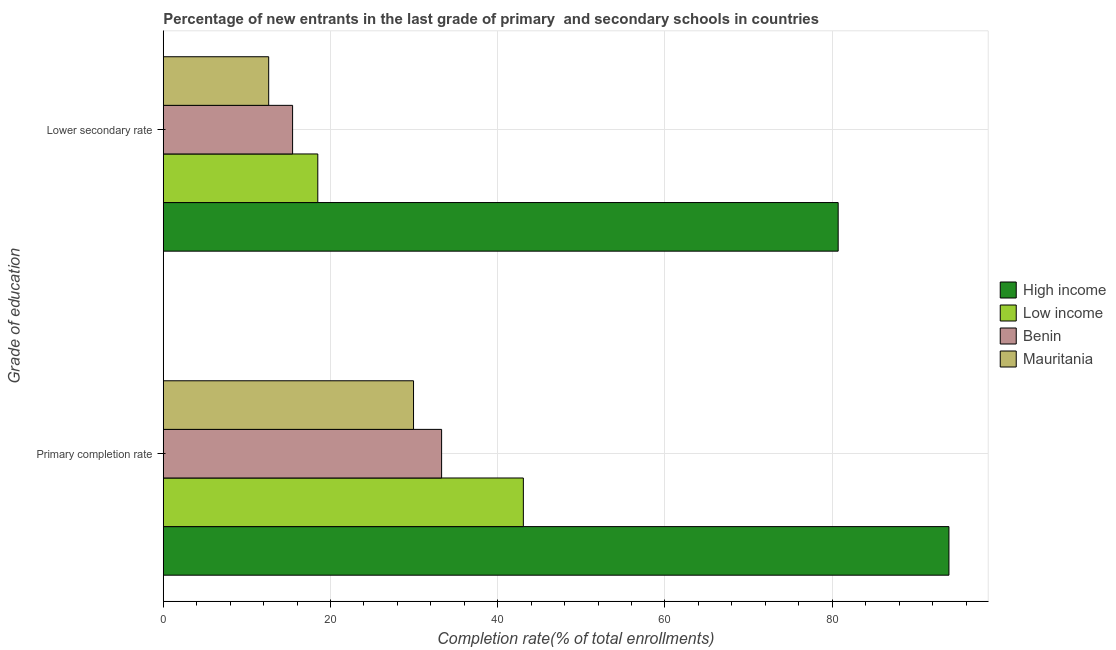How many different coloured bars are there?
Provide a succinct answer. 4. How many groups of bars are there?
Your answer should be compact. 2. Are the number of bars per tick equal to the number of legend labels?
Offer a very short reply. Yes. Are the number of bars on each tick of the Y-axis equal?
Provide a succinct answer. Yes. How many bars are there on the 1st tick from the top?
Keep it short and to the point. 4. What is the label of the 2nd group of bars from the top?
Your answer should be very brief. Primary completion rate. What is the completion rate in secondary schools in High income?
Provide a short and direct response. 80.71. Across all countries, what is the maximum completion rate in secondary schools?
Your response must be concise. 80.71. Across all countries, what is the minimum completion rate in primary schools?
Keep it short and to the point. 29.93. In which country was the completion rate in primary schools maximum?
Your answer should be very brief. High income. In which country was the completion rate in primary schools minimum?
Your answer should be compact. Mauritania. What is the total completion rate in primary schools in the graph?
Offer a very short reply. 200.24. What is the difference between the completion rate in secondary schools in Mauritania and that in Benin?
Your answer should be compact. -2.86. What is the difference between the completion rate in secondary schools in Mauritania and the completion rate in primary schools in Low income?
Give a very brief answer. -30.45. What is the average completion rate in secondary schools per country?
Ensure brevity in your answer.  31.82. What is the difference between the completion rate in primary schools and completion rate in secondary schools in Mauritania?
Ensure brevity in your answer.  17.32. In how many countries, is the completion rate in primary schools greater than 56 %?
Provide a short and direct response. 1. What is the ratio of the completion rate in secondary schools in High income to that in Low income?
Offer a very short reply. 4.37. Is the completion rate in primary schools in Low income less than that in Mauritania?
Make the answer very short. No. In how many countries, is the completion rate in secondary schools greater than the average completion rate in secondary schools taken over all countries?
Provide a short and direct response. 1. What does the 1st bar from the top in Lower secondary rate represents?
Offer a terse response. Mauritania. What does the 2nd bar from the bottom in Primary completion rate represents?
Your response must be concise. Low income. Are all the bars in the graph horizontal?
Provide a succinct answer. Yes. How many countries are there in the graph?
Your answer should be very brief. 4. What is the difference between two consecutive major ticks on the X-axis?
Keep it short and to the point. 20. Does the graph contain any zero values?
Provide a succinct answer. No. How many legend labels are there?
Keep it short and to the point. 4. What is the title of the graph?
Provide a succinct answer. Percentage of new entrants in the last grade of primary  and secondary schools in countries. What is the label or title of the X-axis?
Your answer should be very brief. Completion rate(% of total enrollments). What is the label or title of the Y-axis?
Your answer should be compact. Grade of education. What is the Completion rate(% of total enrollments) in High income in Primary completion rate?
Your answer should be compact. 93.96. What is the Completion rate(% of total enrollments) of Low income in Primary completion rate?
Give a very brief answer. 43.06. What is the Completion rate(% of total enrollments) in Benin in Primary completion rate?
Offer a very short reply. 33.29. What is the Completion rate(% of total enrollments) in Mauritania in Primary completion rate?
Provide a succinct answer. 29.93. What is the Completion rate(% of total enrollments) of High income in Lower secondary rate?
Provide a succinct answer. 80.71. What is the Completion rate(% of total enrollments) of Low income in Lower secondary rate?
Ensure brevity in your answer.  18.48. What is the Completion rate(% of total enrollments) in Benin in Lower secondary rate?
Give a very brief answer. 15.47. What is the Completion rate(% of total enrollments) of Mauritania in Lower secondary rate?
Ensure brevity in your answer.  12.61. Across all Grade of education, what is the maximum Completion rate(% of total enrollments) in High income?
Provide a short and direct response. 93.96. Across all Grade of education, what is the maximum Completion rate(% of total enrollments) of Low income?
Ensure brevity in your answer.  43.06. Across all Grade of education, what is the maximum Completion rate(% of total enrollments) in Benin?
Your answer should be very brief. 33.29. Across all Grade of education, what is the maximum Completion rate(% of total enrollments) in Mauritania?
Provide a short and direct response. 29.93. Across all Grade of education, what is the minimum Completion rate(% of total enrollments) in High income?
Offer a very short reply. 80.71. Across all Grade of education, what is the minimum Completion rate(% of total enrollments) of Low income?
Your response must be concise. 18.48. Across all Grade of education, what is the minimum Completion rate(% of total enrollments) of Benin?
Your response must be concise. 15.47. Across all Grade of education, what is the minimum Completion rate(% of total enrollments) of Mauritania?
Your response must be concise. 12.61. What is the total Completion rate(% of total enrollments) in High income in the graph?
Give a very brief answer. 174.67. What is the total Completion rate(% of total enrollments) in Low income in the graph?
Give a very brief answer. 61.54. What is the total Completion rate(% of total enrollments) of Benin in the graph?
Give a very brief answer. 48.75. What is the total Completion rate(% of total enrollments) of Mauritania in the graph?
Your response must be concise. 42.54. What is the difference between the Completion rate(% of total enrollments) of High income in Primary completion rate and that in Lower secondary rate?
Provide a succinct answer. 13.25. What is the difference between the Completion rate(% of total enrollments) of Low income in Primary completion rate and that in Lower secondary rate?
Provide a succinct answer. 24.58. What is the difference between the Completion rate(% of total enrollments) in Benin in Primary completion rate and that in Lower secondary rate?
Offer a very short reply. 17.82. What is the difference between the Completion rate(% of total enrollments) of Mauritania in Primary completion rate and that in Lower secondary rate?
Offer a terse response. 17.32. What is the difference between the Completion rate(% of total enrollments) in High income in Primary completion rate and the Completion rate(% of total enrollments) in Low income in Lower secondary rate?
Make the answer very short. 75.48. What is the difference between the Completion rate(% of total enrollments) of High income in Primary completion rate and the Completion rate(% of total enrollments) of Benin in Lower secondary rate?
Keep it short and to the point. 78.49. What is the difference between the Completion rate(% of total enrollments) of High income in Primary completion rate and the Completion rate(% of total enrollments) of Mauritania in Lower secondary rate?
Your response must be concise. 81.35. What is the difference between the Completion rate(% of total enrollments) of Low income in Primary completion rate and the Completion rate(% of total enrollments) of Benin in Lower secondary rate?
Provide a succinct answer. 27.6. What is the difference between the Completion rate(% of total enrollments) of Low income in Primary completion rate and the Completion rate(% of total enrollments) of Mauritania in Lower secondary rate?
Your response must be concise. 30.45. What is the difference between the Completion rate(% of total enrollments) of Benin in Primary completion rate and the Completion rate(% of total enrollments) of Mauritania in Lower secondary rate?
Provide a short and direct response. 20.68. What is the average Completion rate(% of total enrollments) in High income per Grade of education?
Offer a very short reply. 87.33. What is the average Completion rate(% of total enrollments) of Low income per Grade of education?
Ensure brevity in your answer.  30.77. What is the average Completion rate(% of total enrollments) in Benin per Grade of education?
Give a very brief answer. 24.38. What is the average Completion rate(% of total enrollments) of Mauritania per Grade of education?
Keep it short and to the point. 21.27. What is the difference between the Completion rate(% of total enrollments) of High income and Completion rate(% of total enrollments) of Low income in Primary completion rate?
Your answer should be very brief. 50.9. What is the difference between the Completion rate(% of total enrollments) in High income and Completion rate(% of total enrollments) in Benin in Primary completion rate?
Provide a succinct answer. 60.67. What is the difference between the Completion rate(% of total enrollments) in High income and Completion rate(% of total enrollments) in Mauritania in Primary completion rate?
Ensure brevity in your answer.  64.03. What is the difference between the Completion rate(% of total enrollments) of Low income and Completion rate(% of total enrollments) of Benin in Primary completion rate?
Provide a short and direct response. 9.78. What is the difference between the Completion rate(% of total enrollments) in Low income and Completion rate(% of total enrollments) in Mauritania in Primary completion rate?
Your answer should be compact. 13.13. What is the difference between the Completion rate(% of total enrollments) in Benin and Completion rate(% of total enrollments) in Mauritania in Primary completion rate?
Your answer should be compact. 3.36. What is the difference between the Completion rate(% of total enrollments) of High income and Completion rate(% of total enrollments) of Low income in Lower secondary rate?
Offer a terse response. 62.23. What is the difference between the Completion rate(% of total enrollments) in High income and Completion rate(% of total enrollments) in Benin in Lower secondary rate?
Keep it short and to the point. 65.24. What is the difference between the Completion rate(% of total enrollments) in High income and Completion rate(% of total enrollments) in Mauritania in Lower secondary rate?
Give a very brief answer. 68.1. What is the difference between the Completion rate(% of total enrollments) of Low income and Completion rate(% of total enrollments) of Benin in Lower secondary rate?
Offer a terse response. 3.01. What is the difference between the Completion rate(% of total enrollments) in Low income and Completion rate(% of total enrollments) in Mauritania in Lower secondary rate?
Provide a short and direct response. 5.87. What is the difference between the Completion rate(% of total enrollments) of Benin and Completion rate(% of total enrollments) of Mauritania in Lower secondary rate?
Your answer should be very brief. 2.86. What is the ratio of the Completion rate(% of total enrollments) in High income in Primary completion rate to that in Lower secondary rate?
Offer a terse response. 1.16. What is the ratio of the Completion rate(% of total enrollments) of Low income in Primary completion rate to that in Lower secondary rate?
Provide a short and direct response. 2.33. What is the ratio of the Completion rate(% of total enrollments) of Benin in Primary completion rate to that in Lower secondary rate?
Your answer should be compact. 2.15. What is the ratio of the Completion rate(% of total enrollments) in Mauritania in Primary completion rate to that in Lower secondary rate?
Provide a short and direct response. 2.37. What is the difference between the highest and the second highest Completion rate(% of total enrollments) of High income?
Your answer should be very brief. 13.25. What is the difference between the highest and the second highest Completion rate(% of total enrollments) in Low income?
Make the answer very short. 24.58. What is the difference between the highest and the second highest Completion rate(% of total enrollments) of Benin?
Offer a very short reply. 17.82. What is the difference between the highest and the second highest Completion rate(% of total enrollments) in Mauritania?
Your answer should be very brief. 17.32. What is the difference between the highest and the lowest Completion rate(% of total enrollments) in High income?
Give a very brief answer. 13.25. What is the difference between the highest and the lowest Completion rate(% of total enrollments) of Low income?
Make the answer very short. 24.58. What is the difference between the highest and the lowest Completion rate(% of total enrollments) of Benin?
Your answer should be very brief. 17.82. What is the difference between the highest and the lowest Completion rate(% of total enrollments) in Mauritania?
Keep it short and to the point. 17.32. 